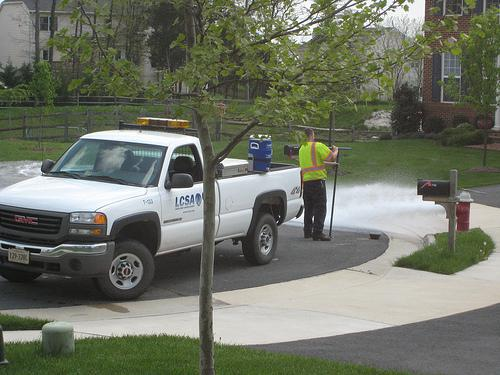Question: what color is the truck?
Choices:
A. Black.
B. Blue.
C. White.
D. Gray.
Answer with the letter. Answer: C 